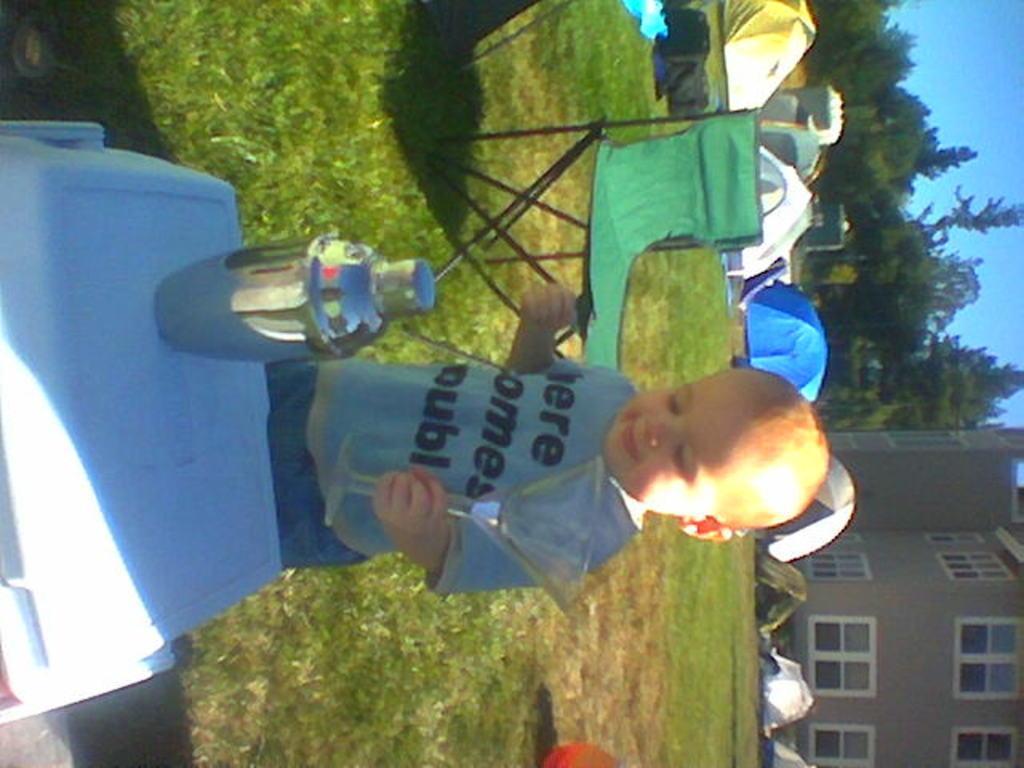Please provide a concise description of this image. In the picture there is a baby catching a glass and standing on the ground, there is a table, on the table there is a bottle, behind the baby there is a chair, there is grass, there are many tents present, there are trees, there is a building, there is a clear sky. 